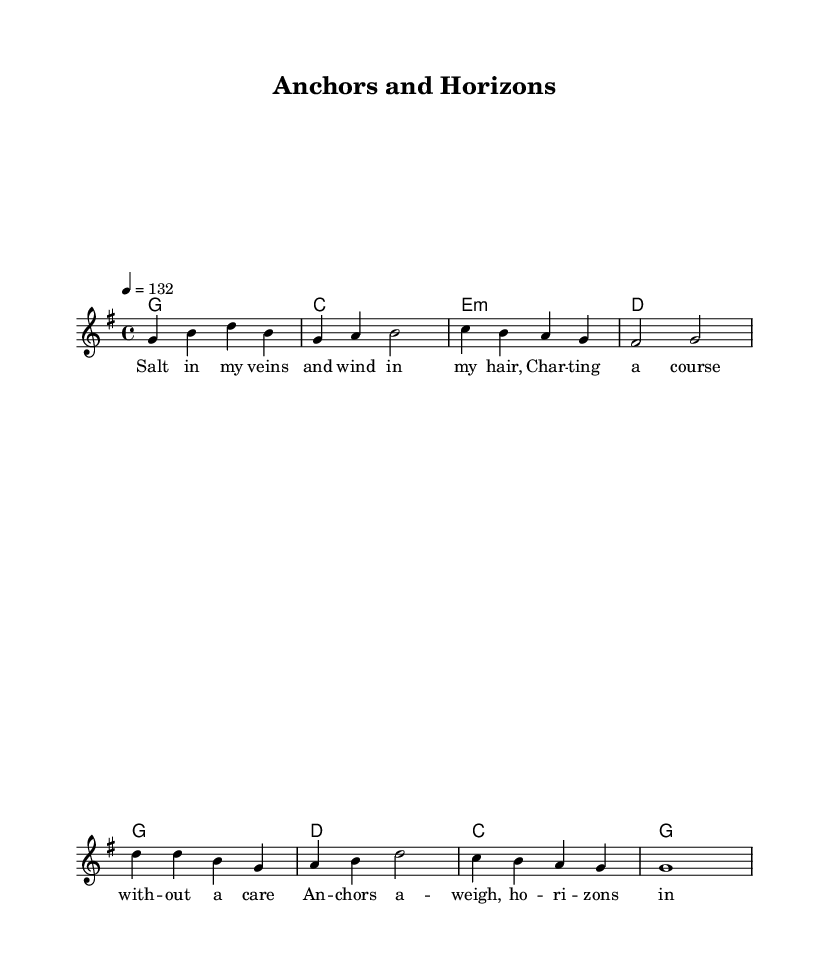What is the key signature of this music? The key signature is G major, which has one sharp (F#).
Answer: G major What is the time signature of this piece? The time signature is 4/4, indicating four beats per measure.
Answer: 4/4 What is the tempo marking for this music? The tempo is indicated as 132 beats per minute, which suggests a lively pace.
Answer: 132 What is the first note of the melody? The melody starts on G, which is the root note in the key of G major.
Answer: G What chords are used in the chorus? The chords in the chorus are G, D, C, and G; these chords are typical in Country Rock for creating a sense of movement and resolution.
Answer: G, D, C, G How many measures are there in the verse section? The verse consists of four measures, each structured to showcase lyrical content and melody harmonically.
Answer: 4 What type of lyrics appears in this song? The lyrics celebrate maritime themes, reflecting seafaring life and heritage as indicated by phrases that evoke imagery of sailing.
Answer: Maritime heritage 